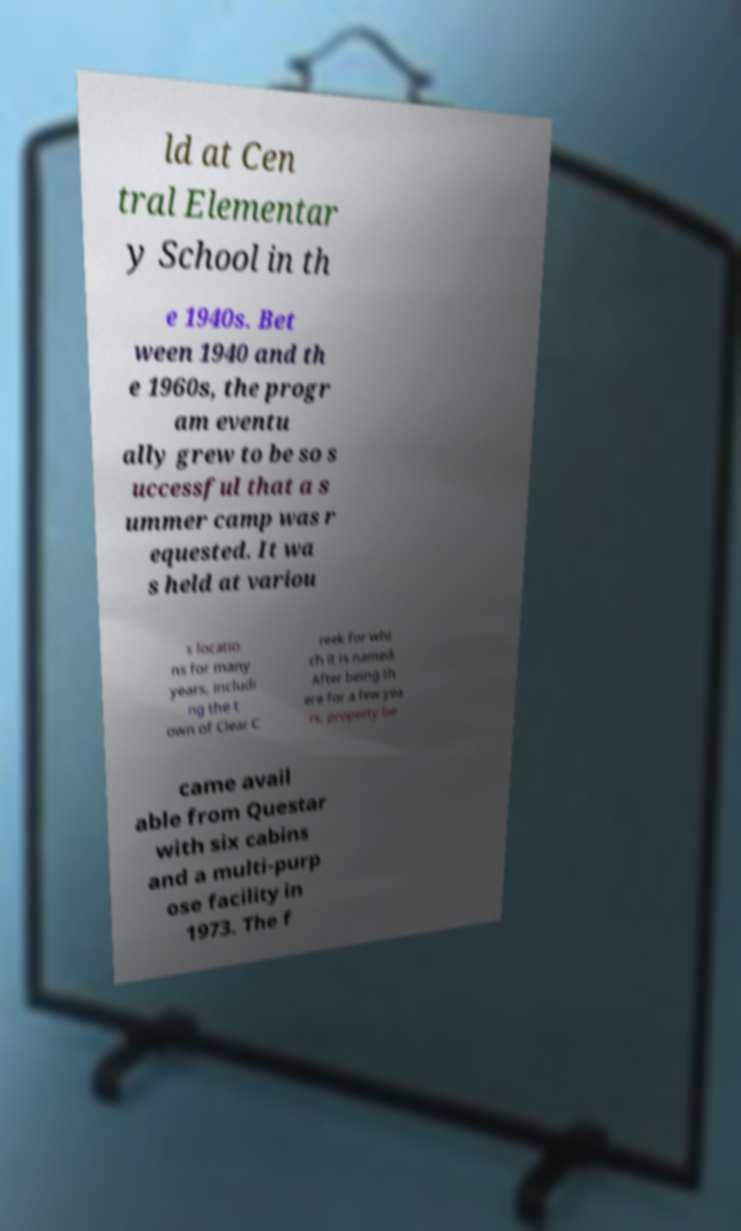Can you read and provide the text displayed in the image?This photo seems to have some interesting text. Can you extract and type it out for me? ld at Cen tral Elementar y School in th e 1940s. Bet ween 1940 and th e 1960s, the progr am eventu ally grew to be so s uccessful that a s ummer camp was r equested. It wa s held at variou s locatio ns for many years, includi ng the t own of Clear C reek for whi ch it is named. After being th ere for a few yea rs, property be came avail able from Questar with six cabins and a multi-purp ose facility in 1973. The f 